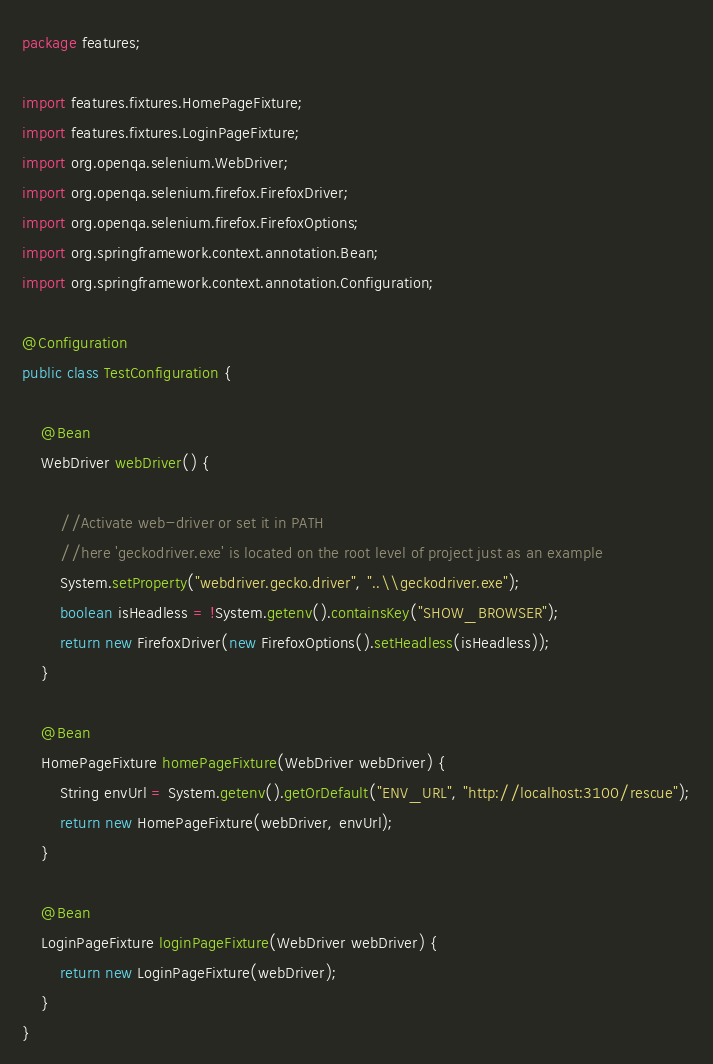<code> <loc_0><loc_0><loc_500><loc_500><_Java_>package features;

import features.fixtures.HomePageFixture;
import features.fixtures.LoginPageFixture;
import org.openqa.selenium.WebDriver;
import org.openqa.selenium.firefox.FirefoxDriver;
import org.openqa.selenium.firefox.FirefoxOptions;
import org.springframework.context.annotation.Bean;
import org.springframework.context.annotation.Configuration;

@Configuration
public class TestConfiguration {

	@Bean
	WebDriver webDriver() {

		//Activate web-driver or set it in PATH
		//here 'geckodriver.exe' is located on the root level of project just as an example
		System.setProperty("webdriver.gecko.driver", "..\\geckodriver.exe");
		boolean isHeadless = !System.getenv().containsKey("SHOW_BROWSER");
		return new FirefoxDriver(new FirefoxOptions().setHeadless(isHeadless));
	}

	@Bean
	HomePageFixture homePageFixture(WebDriver webDriver) {
		String envUrl = System.getenv().getOrDefault("ENV_URL", "http://localhost:3100/rescue");
		return new HomePageFixture(webDriver, envUrl);
	}

	@Bean
	LoginPageFixture loginPageFixture(WebDriver webDriver) {
		return new LoginPageFixture(webDriver);
	}
}
</code> 